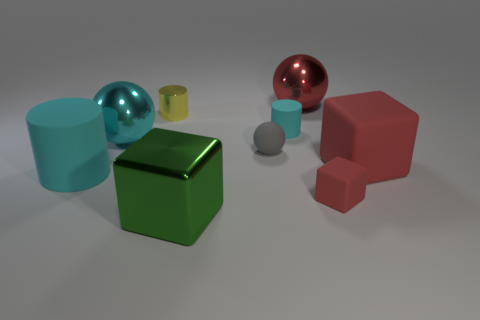Are any small cyan shiny cylinders visible?
Keep it short and to the point. No. The rubber block that is the same size as the green object is what color?
Offer a very short reply. Red. What number of red rubber things are the same shape as the yellow thing?
Provide a succinct answer. 0. Is the red object that is behind the rubber ball made of the same material as the tiny gray object?
Offer a terse response. No. What number of cylinders are large green metal things or yellow metallic things?
Ensure brevity in your answer.  1. There is a large cyan thing behind the big block behind the large cyan cylinder that is behind the large shiny block; what shape is it?
Your answer should be compact. Sphere. What is the shape of the tiny rubber thing that is the same color as the big rubber block?
Make the answer very short. Cube. What number of matte cylinders have the same size as the gray ball?
Make the answer very short. 1. Are there any red metal things to the left of the cyan rubber cylinder in front of the small cyan rubber object?
Offer a very short reply. No. How many things are large metal blocks or tiny red rubber objects?
Make the answer very short. 2. 